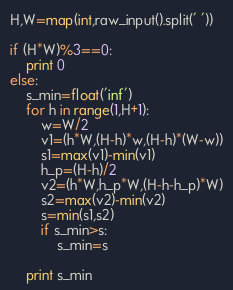<code> <loc_0><loc_0><loc_500><loc_500><_Python_>H,W=map(int,raw_input().split(' '))

if (H*W)%3==0:
    print 0
else:
    s_min=float('inf')
    for h in range(1,H+1):
        w=W/2
        v1=(h*W,(H-h)*w,(H-h)*(W-w))
        s1=max(v1)-min(v1)
        h_p=(H-h)/2
        v2=(h*W,h_p*W,(H-h-h_p)*W)
        s2=max(v2)-min(v2)
        s=min(s1,s2)
        if s_min>s:
            s_min=s

    print s_min</code> 